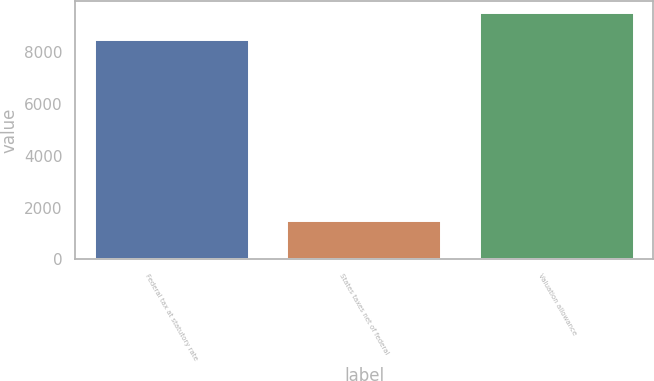Convert chart. <chart><loc_0><loc_0><loc_500><loc_500><bar_chart><fcel>Federal tax at statutory rate<fcel>States taxes net of federal<fcel>Valuation allowance<nl><fcel>8471<fcel>1486<fcel>9520<nl></chart> 